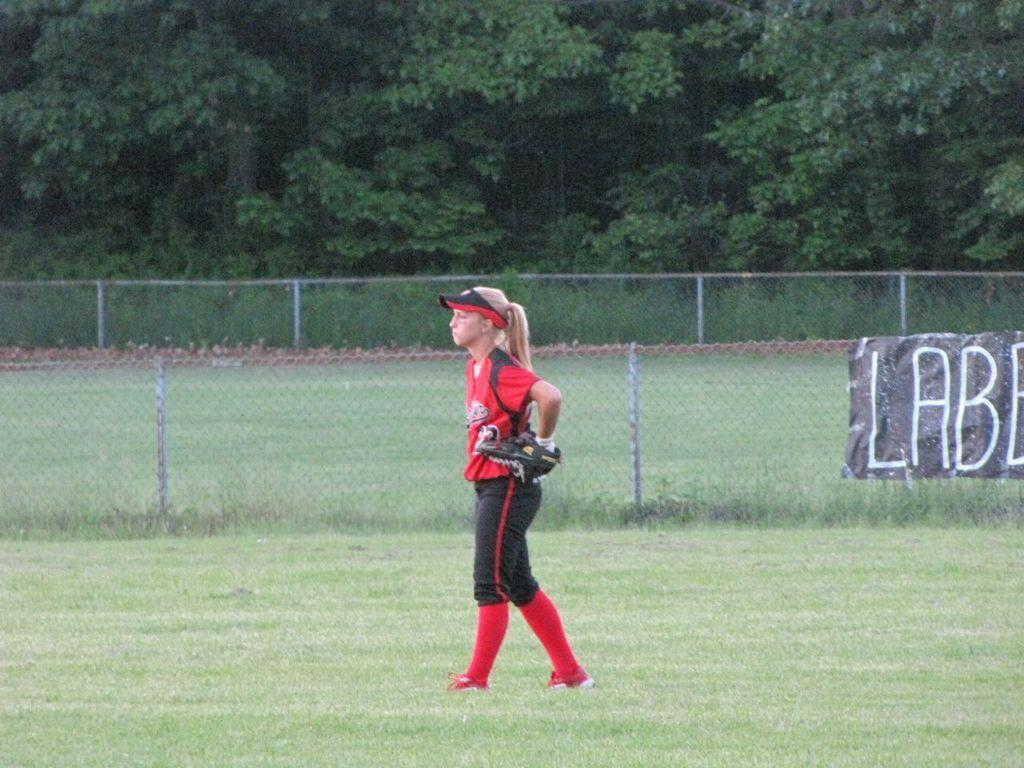<image>
Offer a succinct explanation of the picture presented. A girl in a baseball uniform of a red jersey and black pants stands in the outfield. 